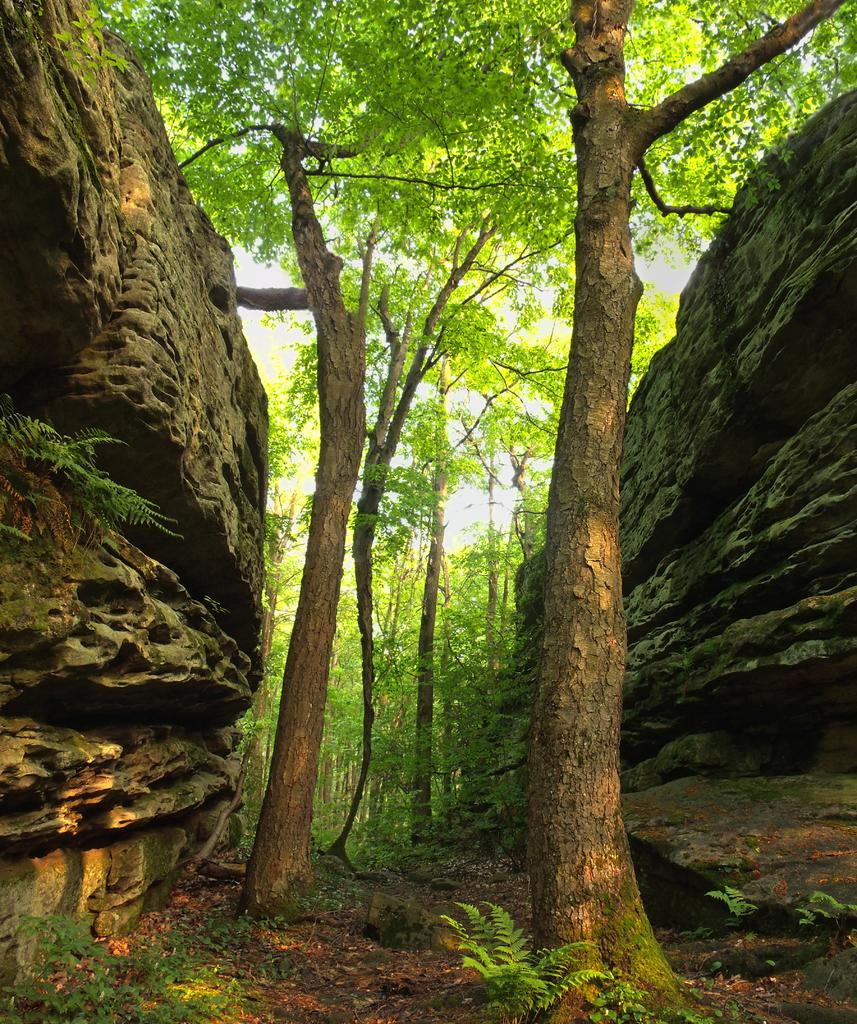What type of vegetation can be seen in the image? There are trees in the image. What is covering the ground in the image? There is grass on the ground in the image. Where is the rock located in the image? The rock is on the left side of the image. How many steps does the boy take on the bridge in the image? There is no boy or bridge present in the image; it only features trees, grass, and a rock. 